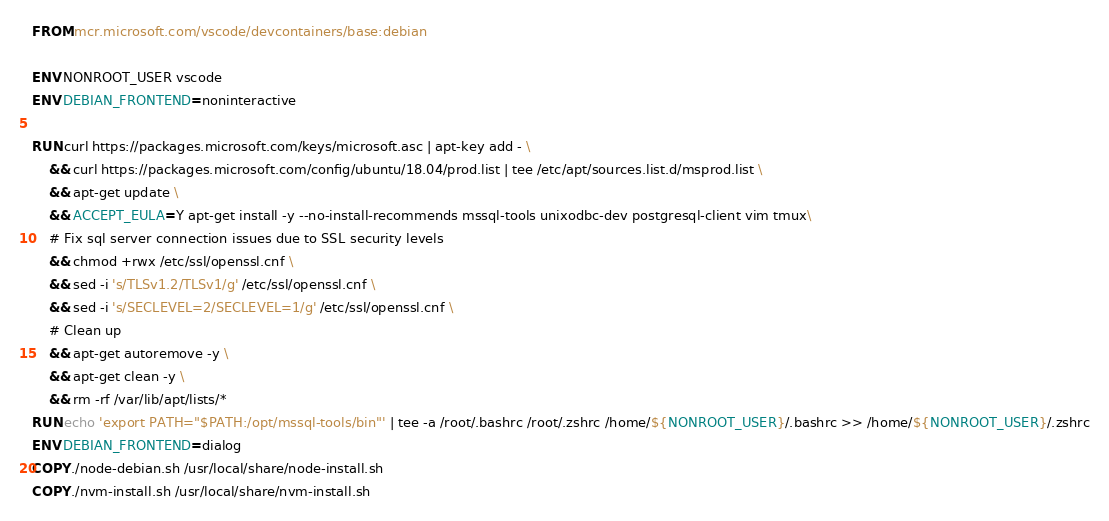<code> <loc_0><loc_0><loc_500><loc_500><_Dockerfile_>FROM mcr.microsoft.com/vscode/devcontainers/base:debian

ENV NONROOT_USER vscode
ENV DEBIAN_FRONTEND=noninteractive

RUN curl https://packages.microsoft.com/keys/microsoft.asc | apt-key add - \
    && curl https://packages.microsoft.com/config/ubuntu/18.04/prod.list | tee /etc/apt/sources.list.d/msprod.list \
    && apt-get update \
    && ACCEPT_EULA=Y apt-get install -y --no-install-recommends mssql-tools unixodbc-dev postgresql-client vim tmux\
    # Fix sql server connection issues due to SSL security levels
    && chmod +rwx /etc/ssl/openssl.cnf \
    && sed -i 's/TLSv1.2/TLSv1/g' /etc/ssl/openssl.cnf \
    && sed -i 's/SECLEVEL=2/SECLEVEL=1/g' /etc/ssl/openssl.cnf \
    # Clean up
    && apt-get autoremove -y \
    && apt-get clean -y \
    && rm -rf /var/lib/apt/lists/*
RUN echo 'export PATH="$PATH:/opt/mssql-tools/bin"' | tee -a /root/.bashrc /root/.zshrc /home/${NONROOT_USER}/.bashrc >> /home/${NONROOT_USER}/.zshrc
ENV DEBIAN_FRONTEND=dialog
COPY ./node-debian.sh /usr/local/share/node-install.sh
COPY ./nvm-install.sh /usr/local/share/nvm-install.sh</code> 